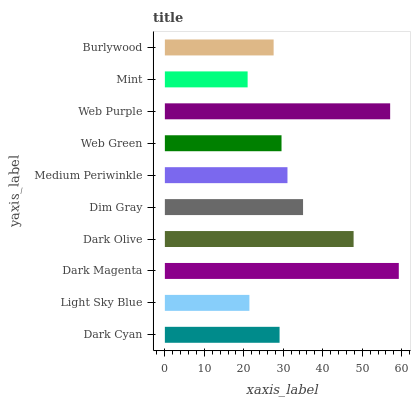Is Mint the minimum?
Answer yes or no. Yes. Is Dark Magenta the maximum?
Answer yes or no. Yes. Is Light Sky Blue the minimum?
Answer yes or no. No. Is Light Sky Blue the maximum?
Answer yes or no. No. Is Dark Cyan greater than Light Sky Blue?
Answer yes or no. Yes. Is Light Sky Blue less than Dark Cyan?
Answer yes or no. Yes. Is Light Sky Blue greater than Dark Cyan?
Answer yes or no. No. Is Dark Cyan less than Light Sky Blue?
Answer yes or no. No. Is Medium Periwinkle the high median?
Answer yes or no. Yes. Is Web Green the low median?
Answer yes or no. Yes. Is Dark Cyan the high median?
Answer yes or no. No. Is Web Purple the low median?
Answer yes or no. No. 